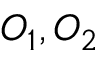<formula> <loc_0><loc_0><loc_500><loc_500>O _ { 1 } , O _ { 2 }</formula> 